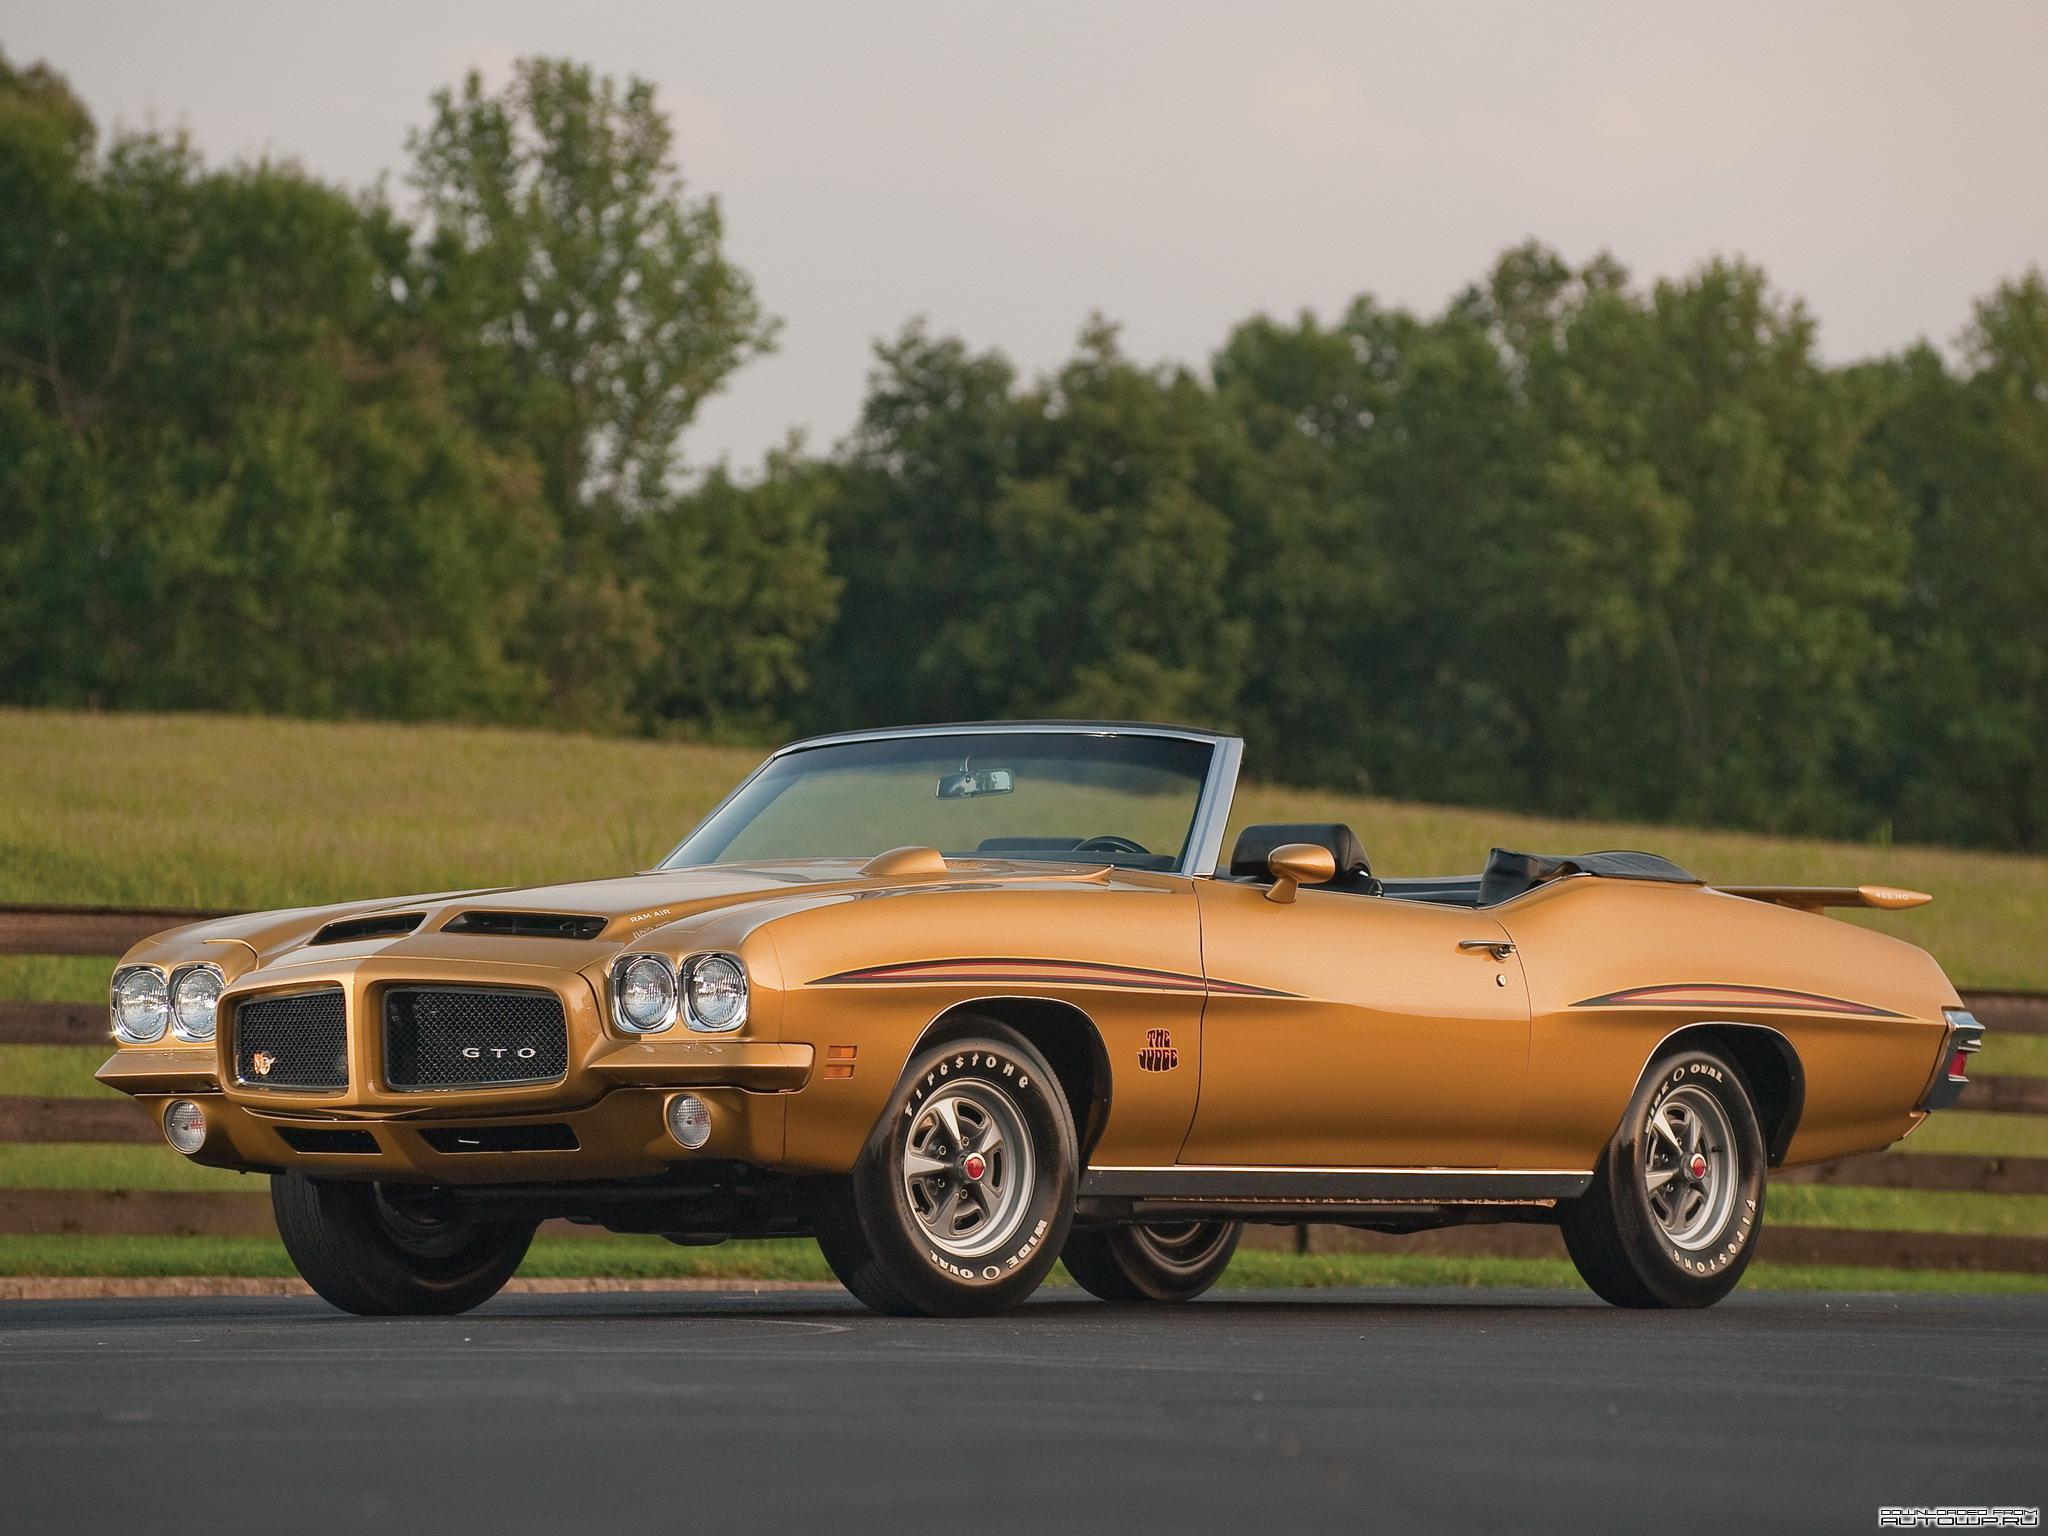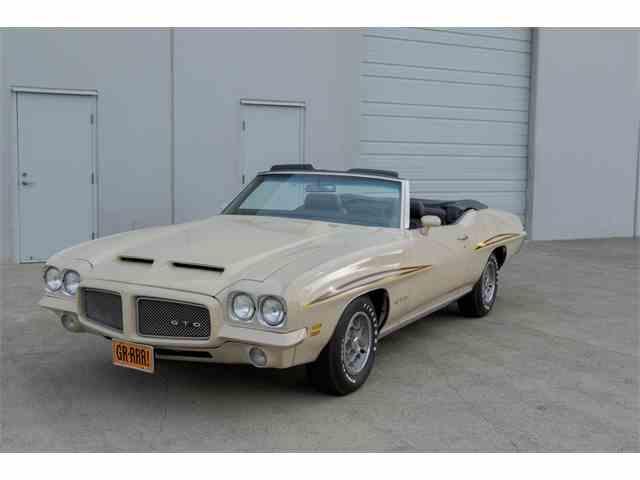The first image is the image on the left, the second image is the image on the right. For the images shown, is this caption "Both vehicles are convertibles." true? Answer yes or no. Yes. 